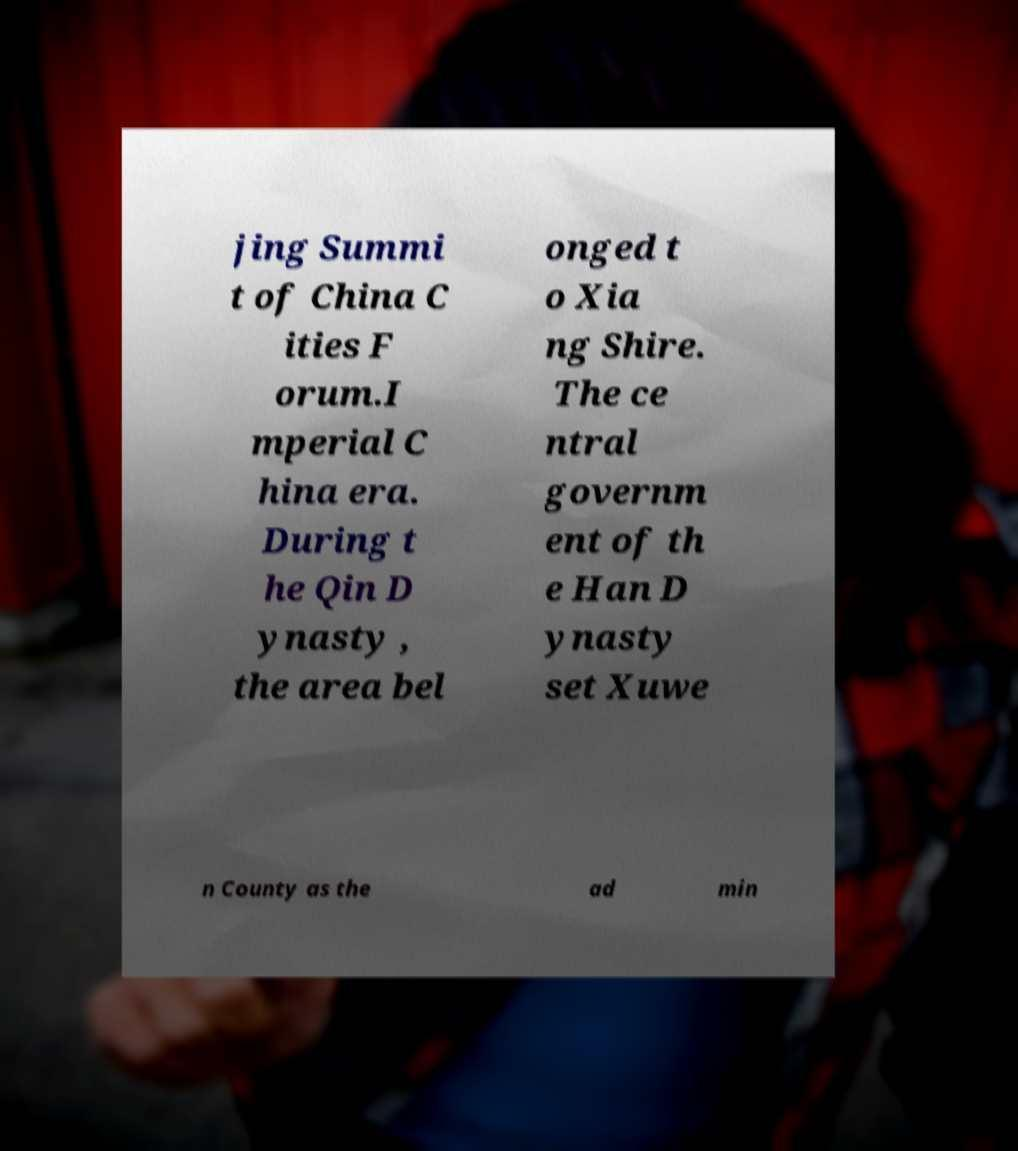There's text embedded in this image that I need extracted. Can you transcribe it verbatim? jing Summi t of China C ities F orum.I mperial C hina era. During t he Qin D ynasty , the area bel onged t o Xia ng Shire. The ce ntral governm ent of th e Han D ynasty set Xuwe n County as the ad min 